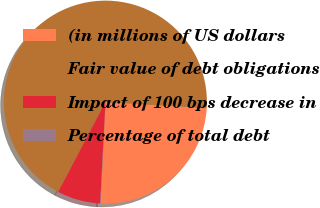Convert chart to OTSL. <chart><loc_0><loc_0><loc_500><loc_500><pie_chart><fcel>(in millions of US dollars<fcel>Fair value of debt obligations<fcel>Impact of 100 bps decrease in<fcel>Percentage of total debt<nl><fcel>24.83%<fcel>68.22%<fcel>6.88%<fcel>0.06%<nl></chart> 